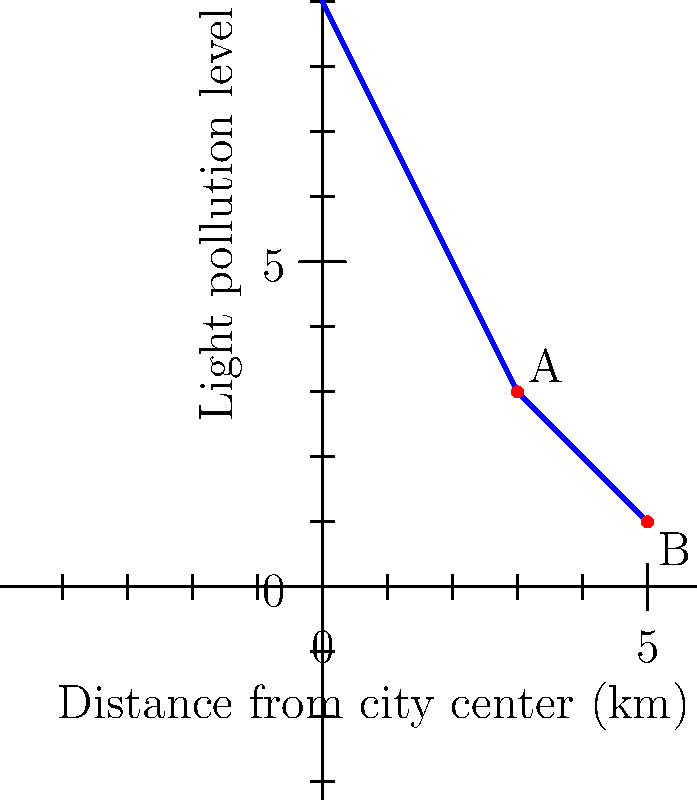Based on the light pollution data shown in the graph, which location (A or B) would be more suitable for an urban astronomy observatory, and why? To determine the most suitable location for an urban astronomy observatory, we need to consider the light pollution levels at each potential site. Let's analyze the data step-by-step:

1. Interpret the graph:
   - The x-axis represents the distance from the city center in kilometers.
   - The y-axis represents the light pollution level (higher values indicate more light pollution).

2. Identify the locations:
   - Location A is at (3 km, 3 light pollution level)
   - Location B is at (5 km, 1 light pollution level)

3. Compare light pollution levels:
   - Location A has a light pollution level of 3
   - Location B has a light pollution level of 1

4. Consider the impact of light pollution on astronomy:
   - Lower light pollution levels are better for astronomical observations.
   - Less light pollution allows for clearer visibility of celestial objects.

5. Evaluate the trade-off between distance and light pollution:
   - Location B is farther from the city center (5 km vs. 3 km).
   - Location B has significantly lower light pollution (1 vs. 3).

6. Make a decision:
   - The lower light pollution level at Location B outweighs the slightly increased distance.
   - The improvement in observing conditions due to reduced light pollution is more critical for an astronomy observatory than the minor increase in distance.

Therefore, Location B would be more suitable for an urban astronomy observatory due to its lower light pollution level, which is crucial for better astronomical observations.
Answer: Location B 